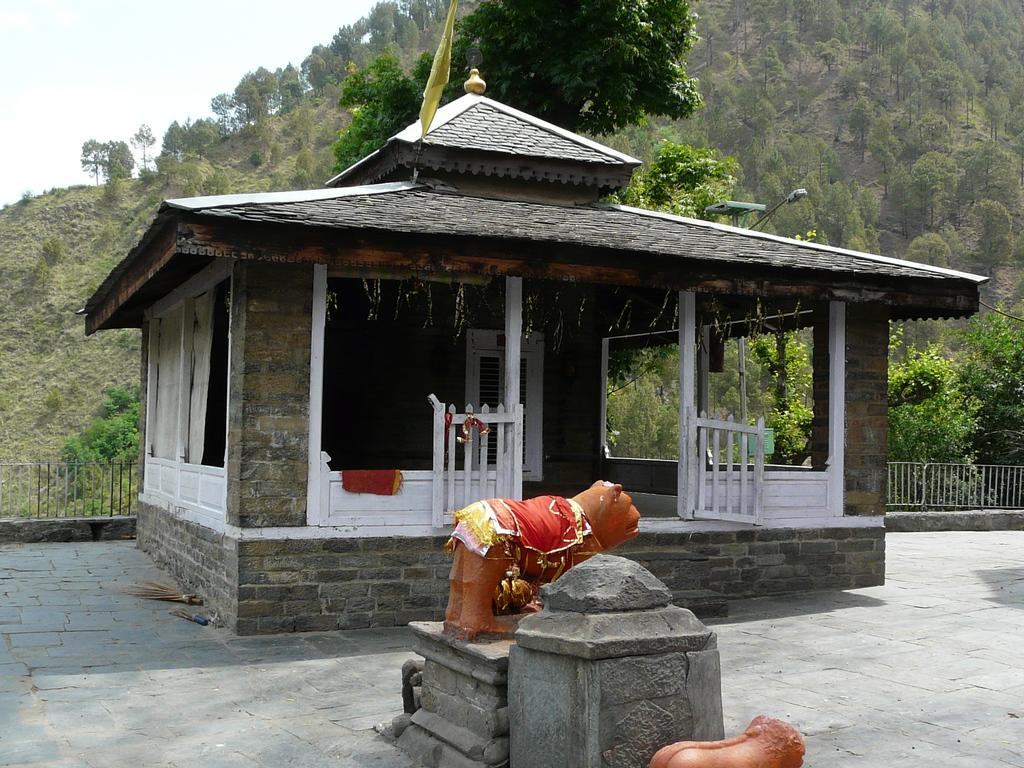What is the main structure in the center of the image? There is a shed in the center of the image. What can be seen at the bottom of the image? There are sculptures at the bottom of the image. What type of material is visible in the image? Stones are visible in the image. What architectural feature is present in the background of the image? There is a fence in the background of the image. What natural elements are visible in the background of the image? Trees and the sky are visible in the background of the image. What form of behavior can be observed in the hour depicted in the image? There is no behavior depicted in the image, and no hour is mentioned. The image features a shed, sculptures, stones, a fence, trees, and the sky in the background. 